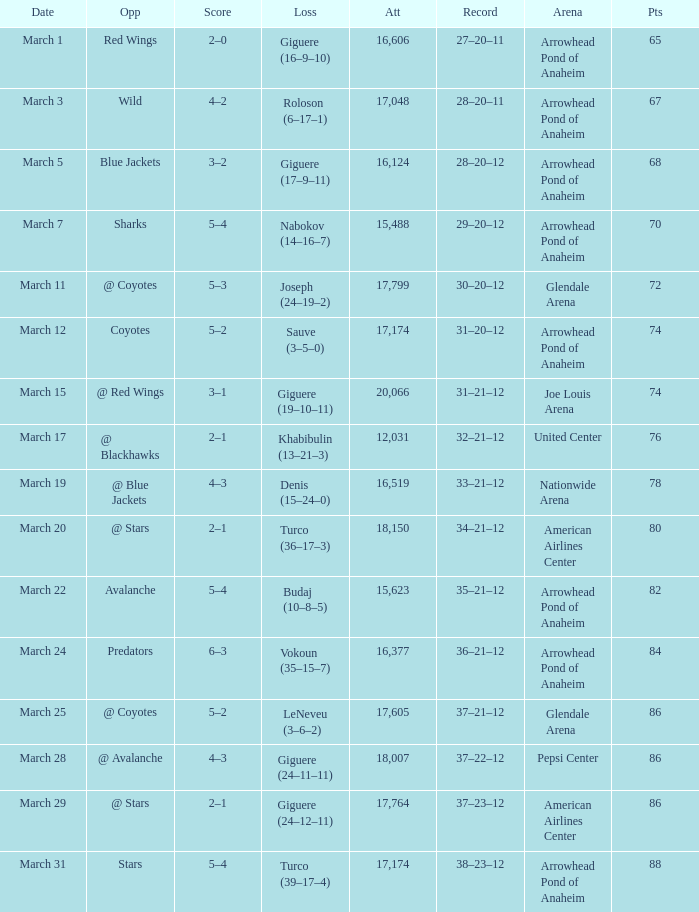What is the Attendance of the game with a Record of 37–21–12 and less than 86 Points? None. 